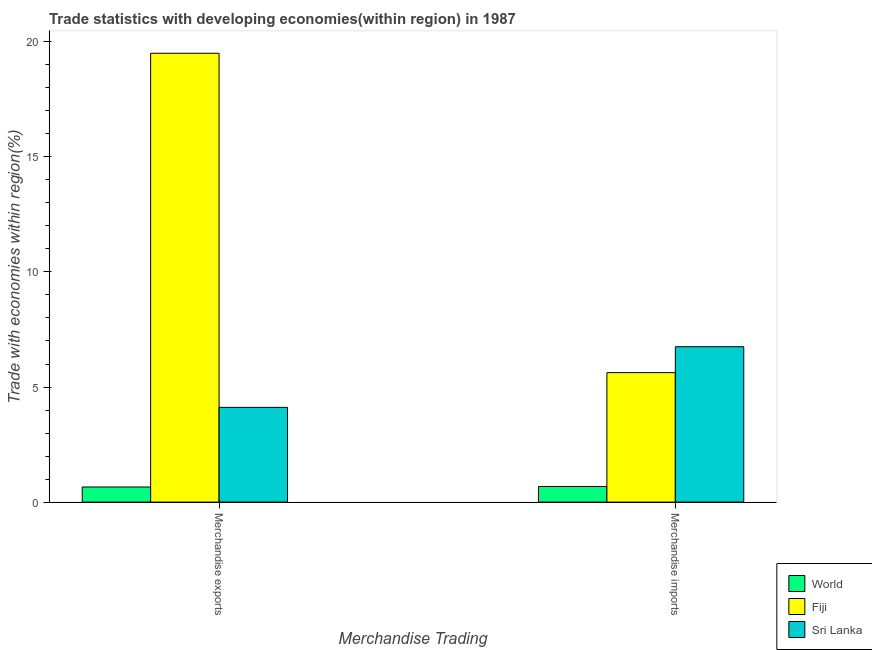How many groups of bars are there?
Offer a terse response. 2. How many bars are there on the 2nd tick from the left?
Provide a succinct answer. 3. How many bars are there on the 1st tick from the right?
Give a very brief answer. 3. What is the label of the 2nd group of bars from the left?
Offer a terse response. Merchandise imports. What is the merchandise exports in World?
Give a very brief answer. 0.66. Across all countries, what is the maximum merchandise exports?
Give a very brief answer. 19.5. Across all countries, what is the minimum merchandise exports?
Your response must be concise. 0.66. In which country was the merchandise exports maximum?
Your answer should be compact. Fiji. In which country was the merchandise imports minimum?
Offer a very short reply. World. What is the total merchandise imports in the graph?
Give a very brief answer. 13.05. What is the difference between the merchandise imports in Sri Lanka and that in World?
Offer a terse response. 6.07. What is the difference between the merchandise exports in Sri Lanka and the merchandise imports in Fiji?
Offer a very short reply. -1.51. What is the average merchandise imports per country?
Keep it short and to the point. 4.35. What is the difference between the merchandise exports and merchandise imports in Sri Lanka?
Your response must be concise. -2.63. What is the ratio of the merchandise exports in Sri Lanka to that in World?
Provide a succinct answer. 6.26. What does the 2nd bar from the right in Merchandise imports represents?
Your answer should be compact. Fiji. What is the difference between two consecutive major ticks on the Y-axis?
Give a very brief answer. 5. Does the graph contain any zero values?
Give a very brief answer. No. Where does the legend appear in the graph?
Provide a succinct answer. Bottom right. How many legend labels are there?
Offer a terse response. 3. What is the title of the graph?
Give a very brief answer. Trade statistics with developing economies(within region) in 1987. Does "American Samoa" appear as one of the legend labels in the graph?
Your answer should be very brief. No. What is the label or title of the X-axis?
Make the answer very short. Merchandise Trading. What is the label or title of the Y-axis?
Give a very brief answer. Trade with economies within region(%). What is the Trade with economies within region(%) of World in Merchandise exports?
Give a very brief answer. 0.66. What is the Trade with economies within region(%) of Fiji in Merchandise exports?
Provide a short and direct response. 19.5. What is the Trade with economies within region(%) in Sri Lanka in Merchandise exports?
Your answer should be very brief. 4.12. What is the Trade with economies within region(%) of World in Merchandise imports?
Your response must be concise. 0.68. What is the Trade with economies within region(%) in Fiji in Merchandise imports?
Your response must be concise. 5.63. What is the Trade with economies within region(%) of Sri Lanka in Merchandise imports?
Offer a terse response. 6.75. Across all Merchandise Trading, what is the maximum Trade with economies within region(%) in World?
Your response must be concise. 0.68. Across all Merchandise Trading, what is the maximum Trade with economies within region(%) in Fiji?
Provide a short and direct response. 19.5. Across all Merchandise Trading, what is the maximum Trade with economies within region(%) in Sri Lanka?
Ensure brevity in your answer.  6.75. Across all Merchandise Trading, what is the minimum Trade with economies within region(%) in World?
Give a very brief answer. 0.66. Across all Merchandise Trading, what is the minimum Trade with economies within region(%) of Fiji?
Ensure brevity in your answer.  5.63. Across all Merchandise Trading, what is the minimum Trade with economies within region(%) of Sri Lanka?
Offer a terse response. 4.12. What is the total Trade with economies within region(%) in World in the graph?
Your response must be concise. 1.33. What is the total Trade with economies within region(%) in Fiji in the graph?
Give a very brief answer. 25.12. What is the total Trade with economies within region(%) in Sri Lanka in the graph?
Provide a succinct answer. 10.87. What is the difference between the Trade with economies within region(%) in World in Merchandise exports and that in Merchandise imports?
Keep it short and to the point. -0.02. What is the difference between the Trade with economies within region(%) of Fiji in Merchandise exports and that in Merchandise imports?
Provide a succinct answer. 13.87. What is the difference between the Trade with economies within region(%) in Sri Lanka in Merchandise exports and that in Merchandise imports?
Your response must be concise. -2.63. What is the difference between the Trade with economies within region(%) of World in Merchandise exports and the Trade with economies within region(%) of Fiji in Merchandise imports?
Offer a terse response. -4.97. What is the difference between the Trade with economies within region(%) in World in Merchandise exports and the Trade with economies within region(%) in Sri Lanka in Merchandise imports?
Give a very brief answer. -6.09. What is the difference between the Trade with economies within region(%) in Fiji in Merchandise exports and the Trade with economies within region(%) in Sri Lanka in Merchandise imports?
Offer a very short reply. 12.75. What is the average Trade with economies within region(%) of World per Merchandise Trading?
Provide a succinct answer. 0.67. What is the average Trade with economies within region(%) of Fiji per Merchandise Trading?
Provide a succinct answer. 12.56. What is the average Trade with economies within region(%) of Sri Lanka per Merchandise Trading?
Your answer should be compact. 5.43. What is the difference between the Trade with economies within region(%) of World and Trade with economies within region(%) of Fiji in Merchandise exports?
Give a very brief answer. -18.84. What is the difference between the Trade with economies within region(%) of World and Trade with economies within region(%) of Sri Lanka in Merchandise exports?
Give a very brief answer. -3.46. What is the difference between the Trade with economies within region(%) of Fiji and Trade with economies within region(%) of Sri Lanka in Merchandise exports?
Ensure brevity in your answer.  15.38. What is the difference between the Trade with economies within region(%) in World and Trade with economies within region(%) in Fiji in Merchandise imports?
Keep it short and to the point. -4.95. What is the difference between the Trade with economies within region(%) of World and Trade with economies within region(%) of Sri Lanka in Merchandise imports?
Give a very brief answer. -6.07. What is the difference between the Trade with economies within region(%) in Fiji and Trade with economies within region(%) in Sri Lanka in Merchandise imports?
Ensure brevity in your answer.  -1.13. What is the ratio of the Trade with economies within region(%) in World in Merchandise exports to that in Merchandise imports?
Offer a very short reply. 0.97. What is the ratio of the Trade with economies within region(%) of Fiji in Merchandise exports to that in Merchandise imports?
Keep it short and to the point. 3.47. What is the ratio of the Trade with economies within region(%) of Sri Lanka in Merchandise exports to that in Merchandise imports?
Your response must be concise. 0.61. What is the difference between the highest and the second highest Trade with economies within region(%) in World?
Provide a short and direct response. 0.02. What is the difference between the highest and the second highest Trade with economies within region(%) of Fiji?
Provide a short and direct response. 13.87. What is the difference between the highest and the second highest Trade with economies within region(%) of Sri Lanka?
Make the answer very short. 2.63. What is the difference between the highest and the lowest Trade with economies within region(%) in World?
Keep it short and to the point. 0.02. What is the difference between the highest and the lowest Trade with economies within region(%) in Fiji?
Give a very brief answer. 13.87. What is the difference between the highest and the lowest Trade with economies within region(%) of Sri Lanka?
Offer a very short reply. 2.63. 